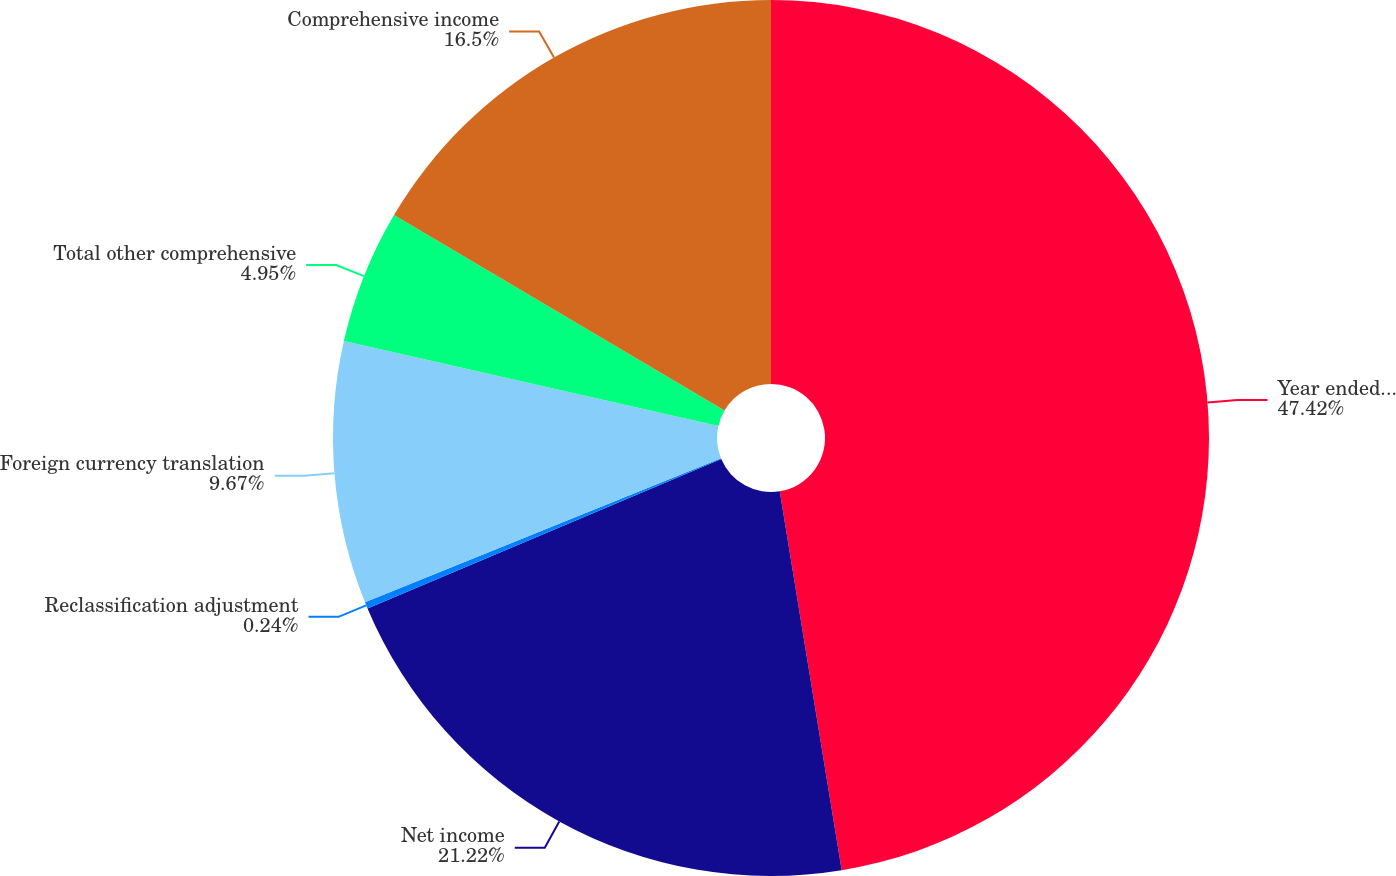Convert chart to OTSL. <chart><loc_0><loc_0><loc_500><loc_500><pie_chart><fcel>Year ended December 31<fcel>Net income<fcel>Reclassification adjustment<fcel>Foreign currency translation<fcel>Total other comprehensive<fcel>Comprehensive income<nl><fcel>47.42%<fcel>21.22%<fcel>0.24%<fcel>9.67%<fcel>4.95%<fcel>16.5%<nl></chart> 